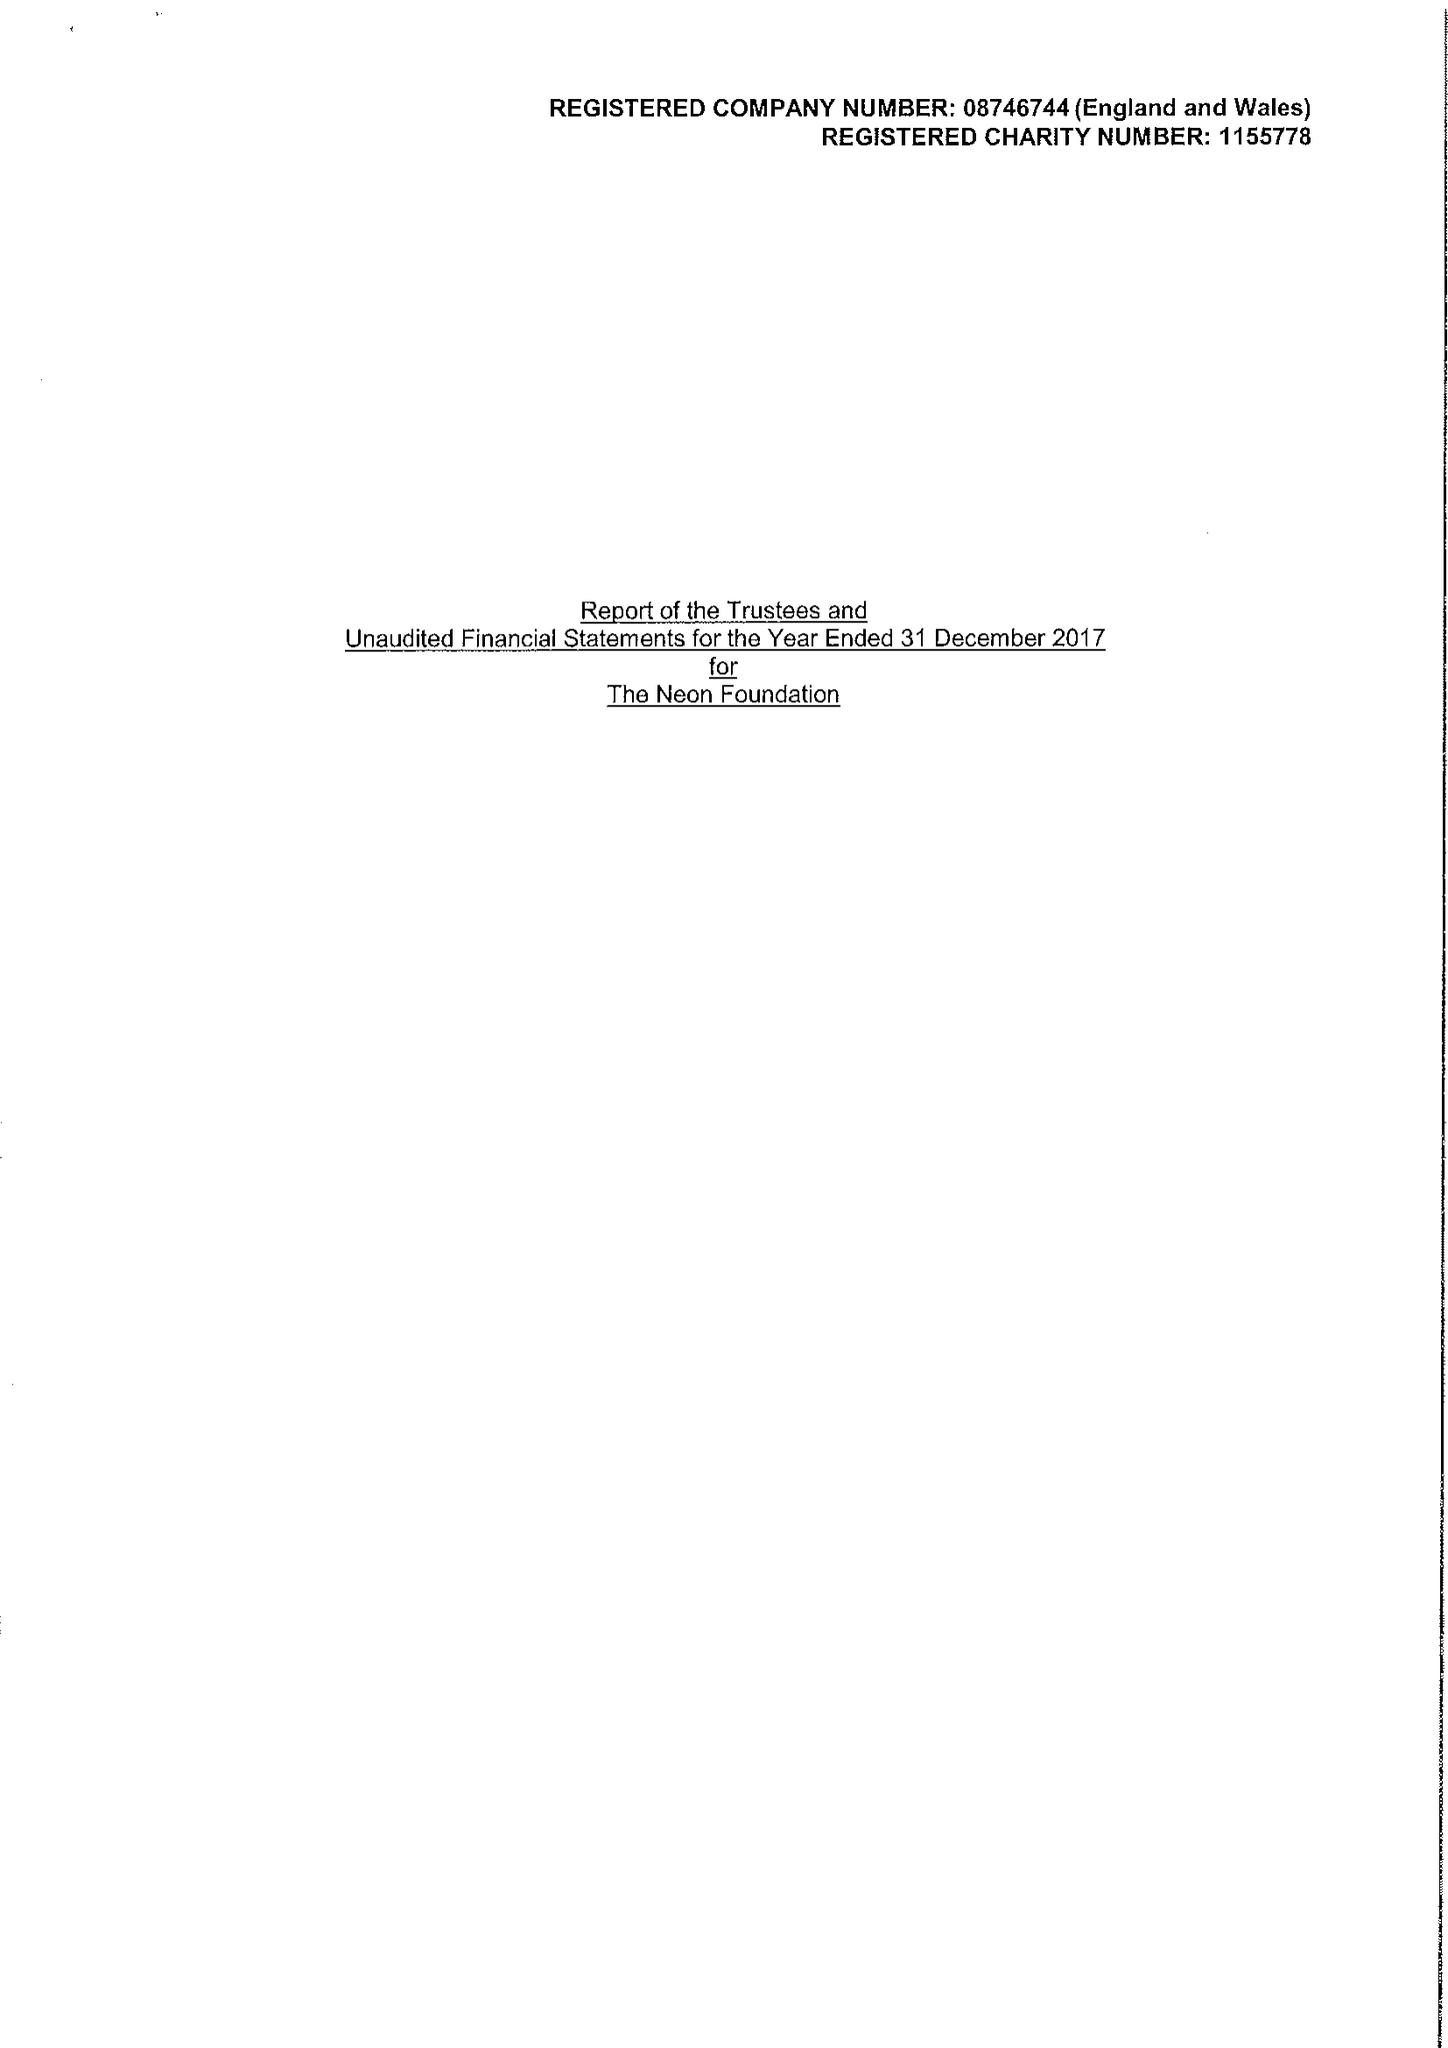What is the value for the report_date?
Answer the question using a single word or phrase. 2017-12-31 